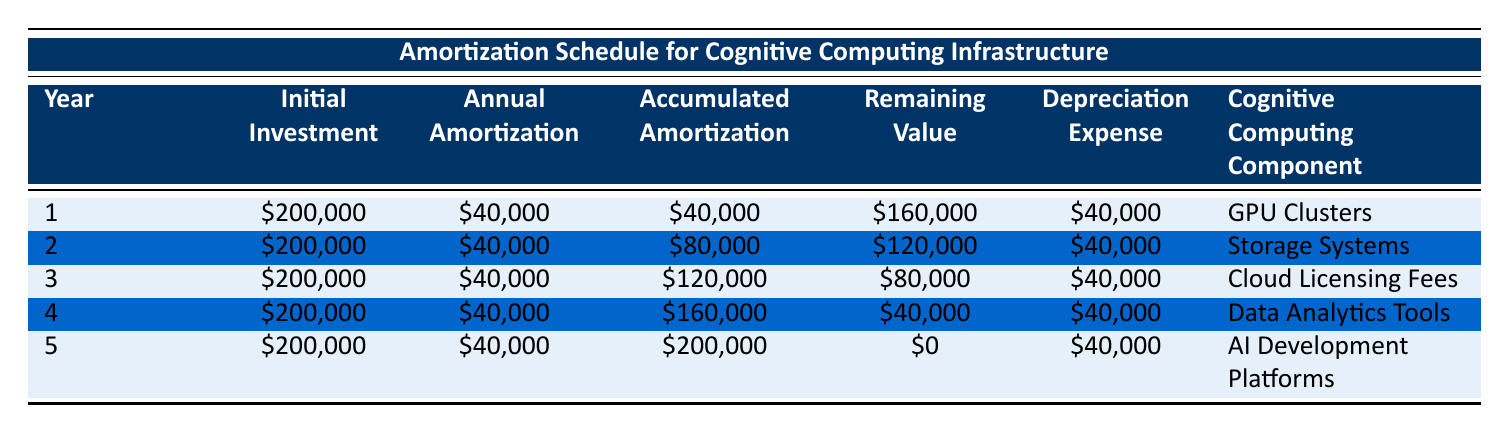What is the initial investment for year 3? From the table, the initial investment for year 3 is listed under the "Initial Investment" column, which shows the value as 200,000.
Answer: 200,000 What is the annual amortization amount for the cognitive computing component in year 4? The annual amortization amount is provided under the "Annual Amortization" column for year 4, and it shows as 40,000.
Answer: 40,000 How much depreciation expense was recognized in total over the 5-year period? To find the total depreciation expense, sum the annual depreciation expenses for each year: 40,000 + 40,000 + 40,000 + 40,000 + 40,000 = 200,000.
Answer: 200,000 Is the remaining value of the AI Development Platforms greater than zero at the end of year 5? According to the table, the remaining value for year 5 is shown as 0. Therefore, it is not greater than zero, so the answer is false.
Answer: No What is the total accumulated amortization at the end of year 3? The accumulated amortization at the end of year 3 is recorded in the table as 120,000, which is the cumulative sum of annual amortization up to that year: 40,000 + 40,000 + 40,000.
Answer: 120,000 Which cognitive computing component had the highest remaining value at the end of its amortization period? At the end of year 3, the remaining value for the Cloud Licensing Fees is 80,000, which is higher than the remaining values for the other components. Hence, it had the highest remaining value.
Answer: Cloud Licensing Fees What is the average annual amortization over the 5 years? The average annual amortization can be calculated by dividing the total amortization over the 5 years (200,000) by the number of years (5): 200,000 / 5 = 40,000.
Answer: 40,000 In which year did the Data Analytics Tools have an accumulated amortization of 160,000? The table indicates that the accumulated amortization reached 160,000 at the end of year 4, confirming that it was in year 4.
Answer: Year 4 What is the remaining value for the Storage Systems after year 2? For year 2, the remaining value captured in the table is 120,000. This value is specifically stated under the "Remaining Value" column for year 2.
Answer: 120,000 